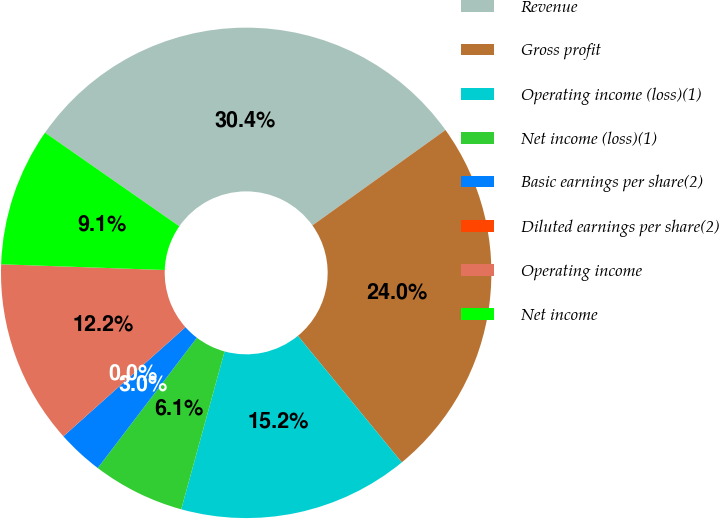Convert chart to OTSL. <chart><loc_0><loc_0><loc_500><loc_500><pie_chart><fcel>Revenue<fcel>Gross profit<fcel>Operating income (loss)(1)<fcel>Net income (loss)(1)<fcel>Basic earnings per share(2)<fcel>Diluted earnings per share(2)<fcel>Operating income<fcel>Net income<nl><fcel>30.42%<fcel>23.96%<fcel>15.21%<fcel>6.08%<fcel>3.04%<fcel>0.0%<fcel>12.17%<fcel>9.13%<nl></chart> 